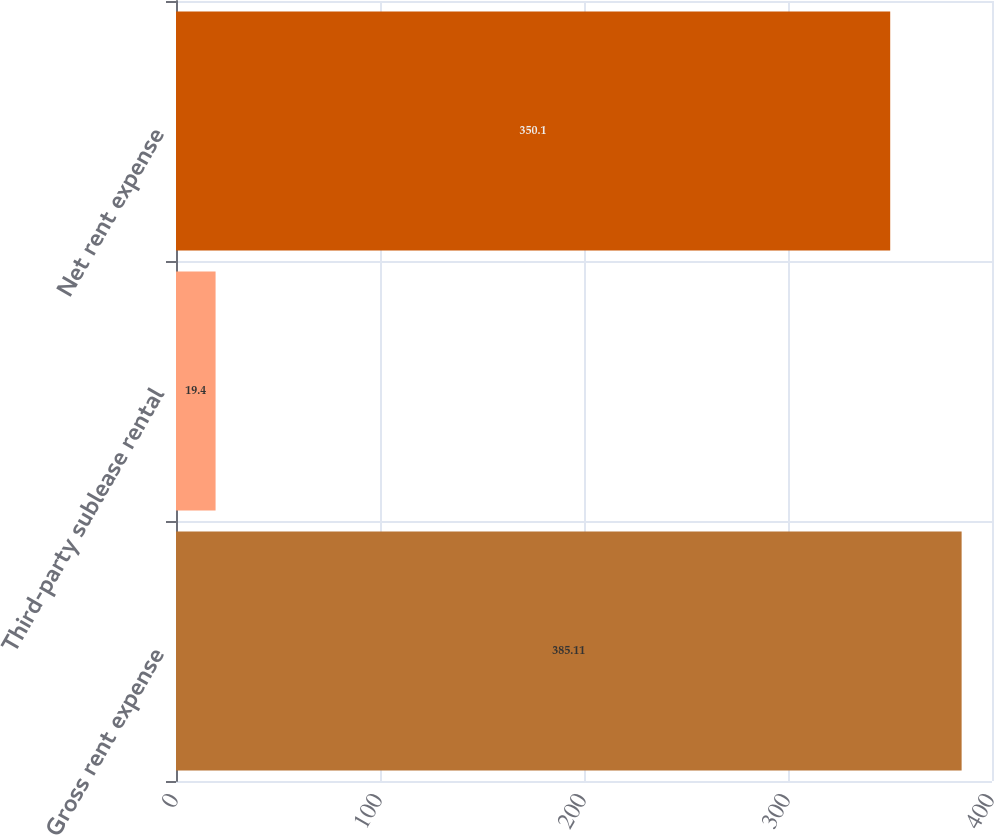Convert chart to OTSL. <chart><loc_0><loc_0><loc_500><loc_500><bar_chart><fcel>Gross rent expense<fcel>Third-party sublease rental<fcel>Net rent expense<nl><fcel>385.11<fcel>19.4<fcel>350.1<nl></chart> 